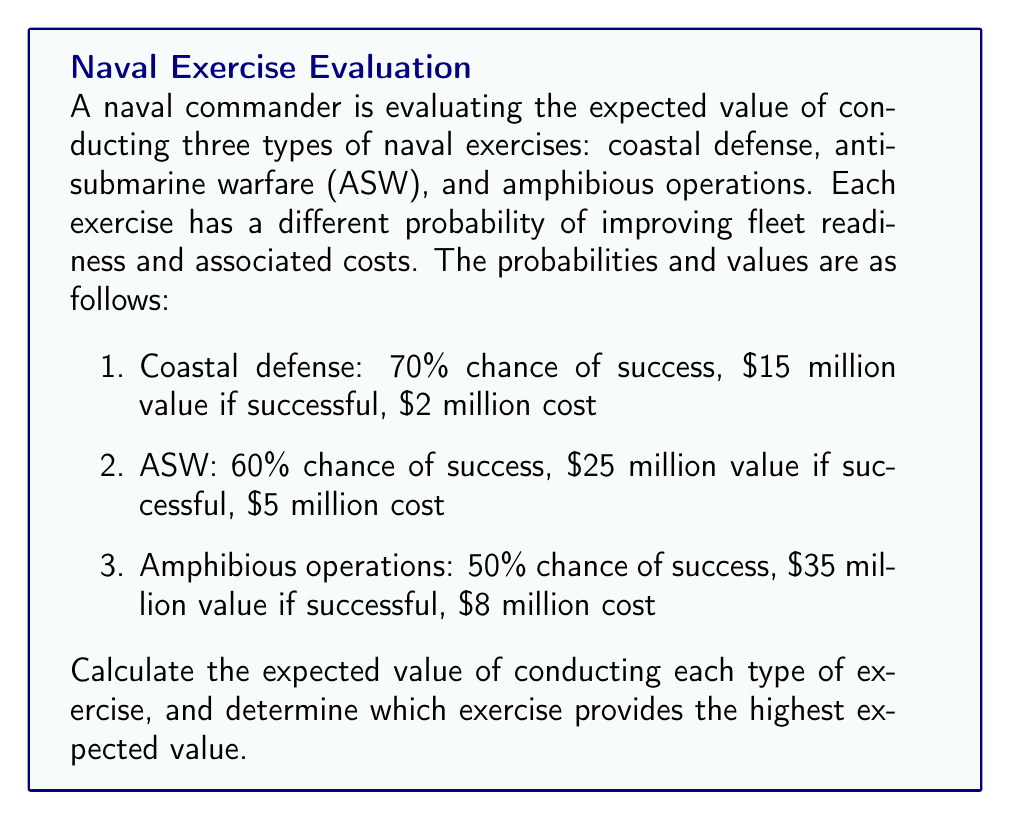Help me with this question. To solve this problem, we need to calculate the expected value for each type of naval exercise using the given probabilities, values, and costs. The expected value formula is:

$$ E(X) = (P(\text{success}) \times \text{Value if successful}) + (P(\text{failure}) \times \text{Value if failed}) - \text{Cost} $$

Let's calculate the expected value for each exercise:

1. Coastal defense:
   $$ E(\text{Coastal}) = (0.70 \times \$15\text{M}) + (0.30 \times \$0) - \$2\text{M} $$
   $$ E(\text{Coastal}) = \$10.5\text{M} - \$2\text{M} = \$8.5\text{M} $$

2. Anti-submarine warfare (ASW):
   $$ E(\text{ASW}) = (0.60 \times \$25\text{M}) + (0.40 \times \$0) - \$5\text{M} $$
   $$ E(\text{ASW}) = \$15\text{M} - \$5\text{M} = \$10\text{M} $$

3. Amphibious operations:
   $$ E(\text{Amphibious}) = (0.50 \times \$35\text{M}) + (0.50 \times \$0) - \$8\text{M} $$
   $$ E(\text{Amphibious}) = \$17.5\text{M} - \$8\text{M} = \$9.5\text{M} $$

To determine which exercise provides the highest expected value, we compare the results:

$$ E(\text{Coastal}) = \$8.5\text{M} $$
$$ E(\text{ASW}) = \$10\text{M} $$
$$ E(\text{Amphibious}) = \$9.5\text{M} $$

The anti-submarine warfare (ASW) exercise has the highest expected value at $10 million.
Answer: The expected values for each exercise are:
Coastal defense: $8.5 million
Anti-submarine warfare (ASW): $10 million
Amphibious operations: $9.5 million

The exercise that provides the highest expected value is anti-submarine warfare (ASW) at $10 million. 